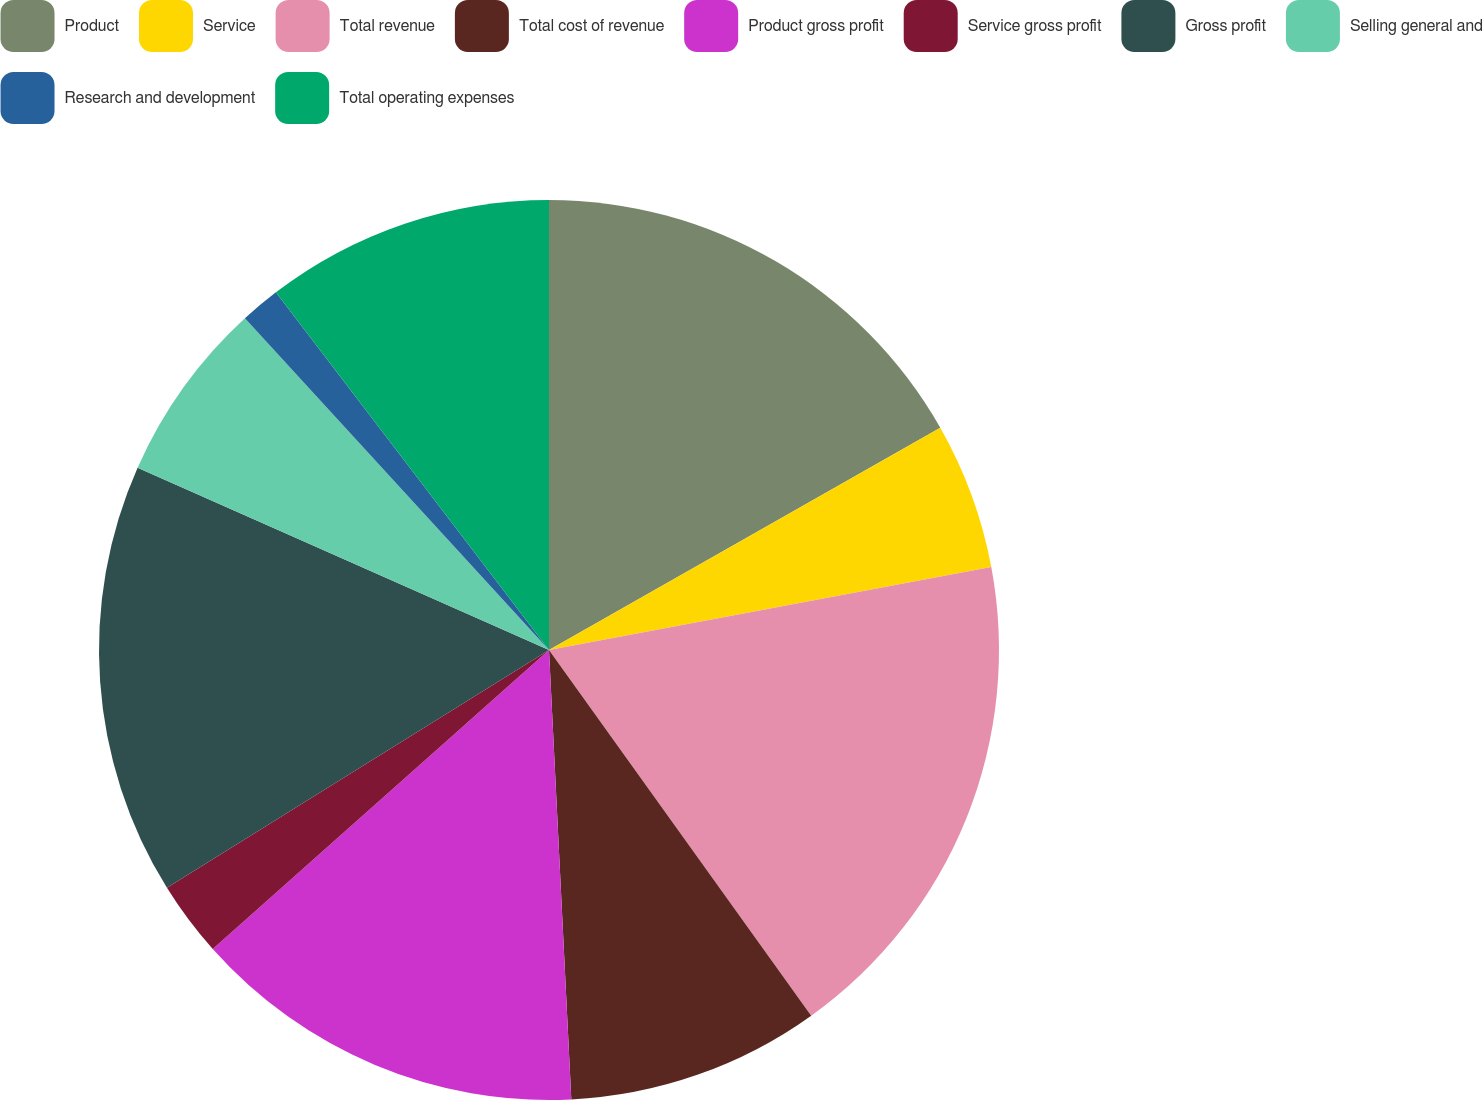<chart> <loc_0><loc_0><loc_500><loc_500><pie_chart><fcel>Product<fcel>Service<fcel>Total revenue<fcel>Total cost of revenue<fcel>Product gross profit<fcel>Service gross profit<fcel>Gross profit<fcel>Selling general and<fcel>Research and development<fcel>Total operating expenses<nl><fcel>16.78%<fcel>5.27%<fcel>18.05%<fcel>9.11%<fcel>14.22%<fcel>2.71%<fcel>15.5%<fcel>6.55%<fcel>1.43%<fcel>10.38%<nl></chart> 